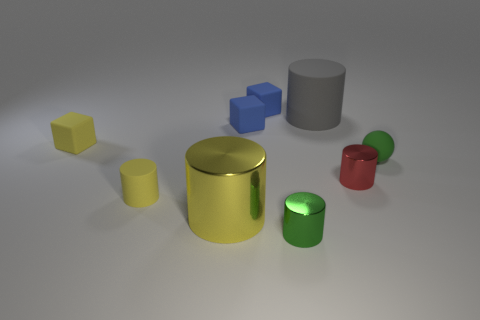How do you think these objects would feel to the touch? Given their smooth and shiny surfaces, the cylinders would probably feel sleek and cool to the touch if they are made of metal, or slightly warm and plasticky if they are made of a reflective plastic material. Their surfaces are likely to be hard and solid, possibly with a slight texture or temperature variance due to the lighting and environmental conditions. 